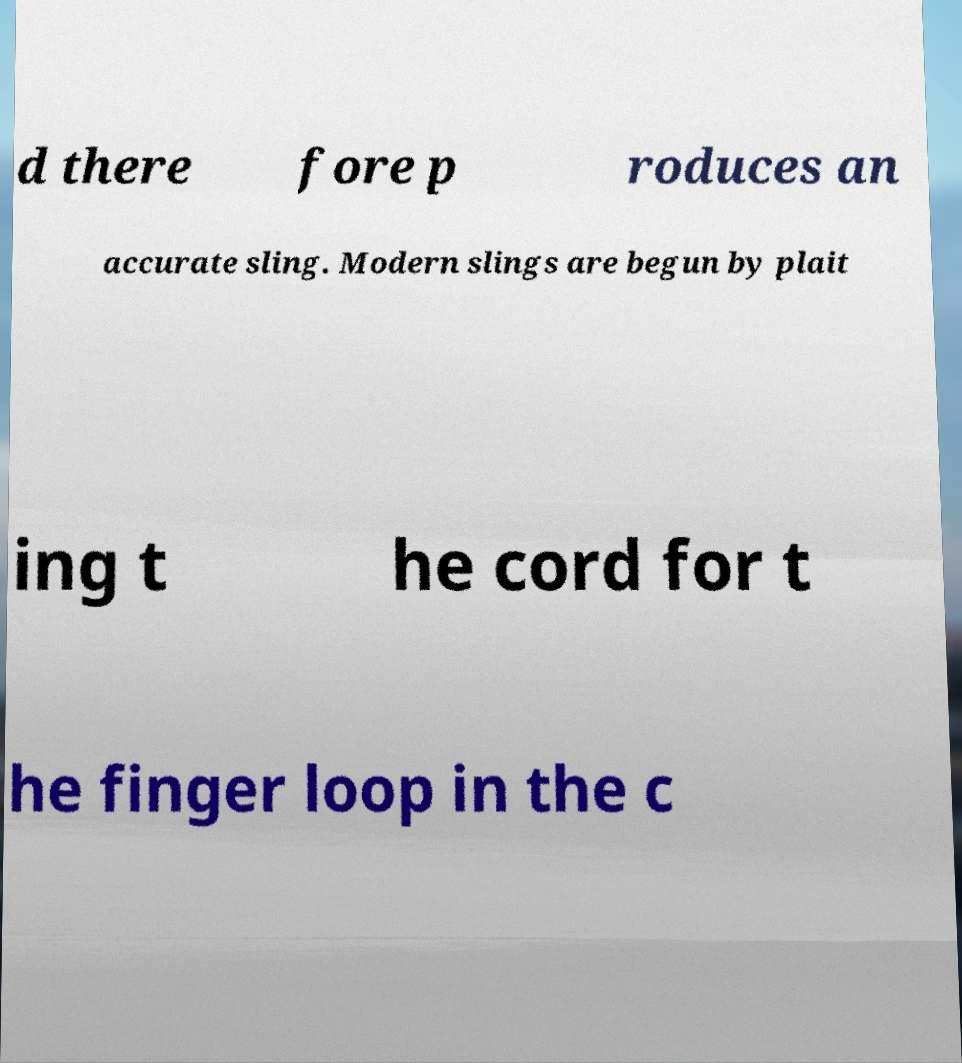Can you read and provide the text displayed in the image?This photo seems to have some interesting text. Can you extract and type it out for me? d there fore p roduces an accurate sling. Modern slings are begun by plait ing t he cord for t he finger loop in the c 